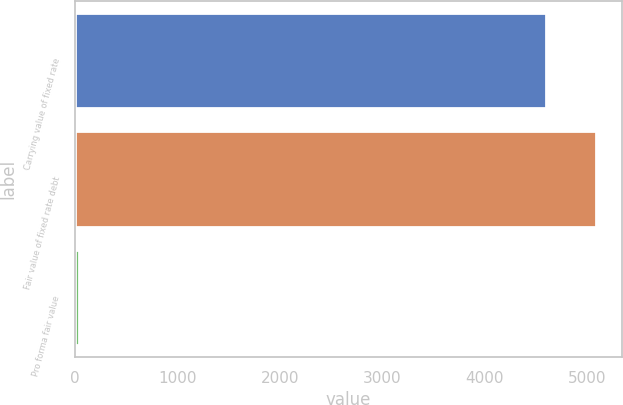<chart> <loc_0><loc_0><loc_500><loc_500><bar_chart><fcel>Carrying value of fixed rate<fcel>Fair value of fixed rate debt<fcel>Pro forma fair value<nl><fcel>4604<fcel>5088.6<fcel>36<nl></chart> 